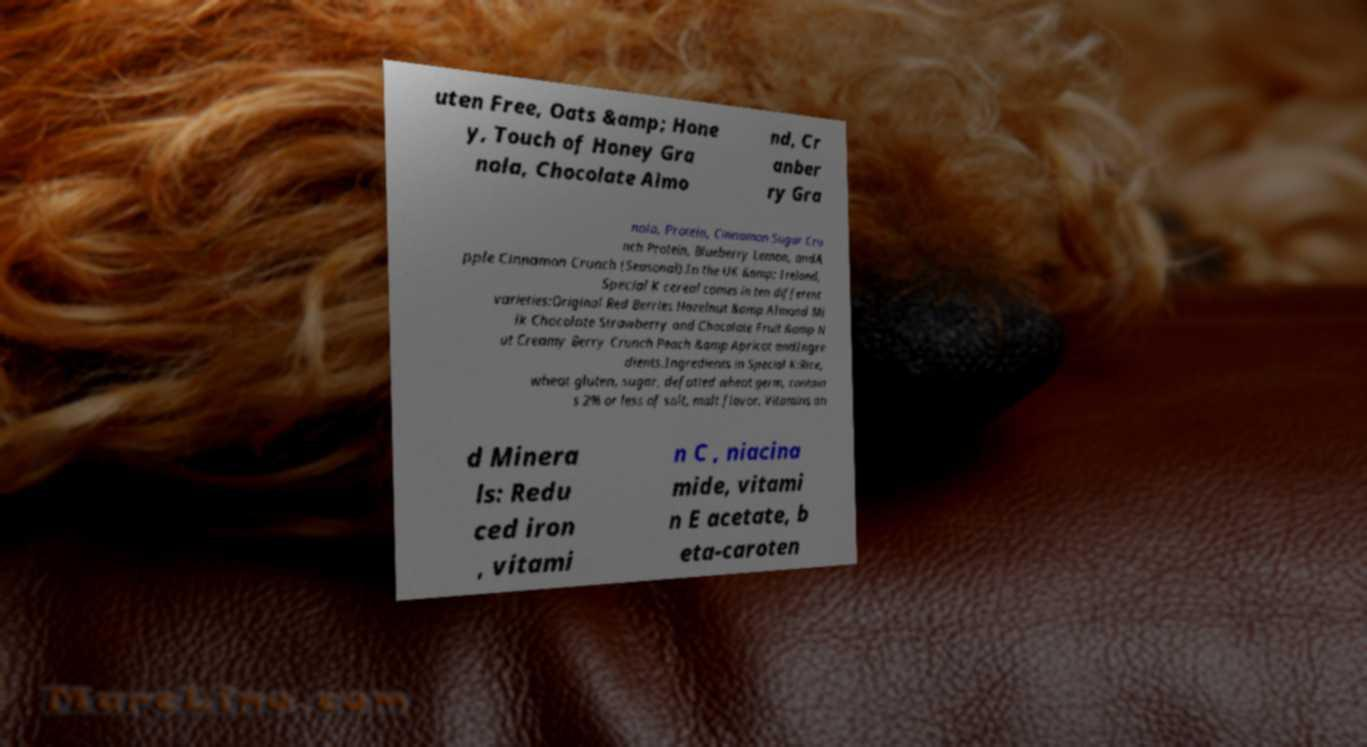There's text embedded in this image that I need extracted. Can you transcribe it verbatim? uten Free, Oats &amp; Hone y, Touch of Honey Gra nola, Chocolate Almo nd, Cr anber ry Gra nola, Protein, Cinnamon Sugar Cru nch Protein, Blueberry Lemon, andA pple Cinnamon Crunch (Seasonal).In the UK &amp; Ireland, Special K cereal comes in ten different varieties:Original Red Berries Hazelnut &amp Almond Mi lk Chocolate Strawberry and Chocolate Fruit &amp N ut Creamy Berry Crunch Peach &amp Apricot andIngre dients.Ingredients in Special K:Rice, wheat gluten, sugar, defatted wheat germ, contain s 2% or less of salt, malt flavor. Vitamins an d Minera ls: Redu ced iron , vitami n C , niacina mide, vitami n E acetate, b eta-caroten 